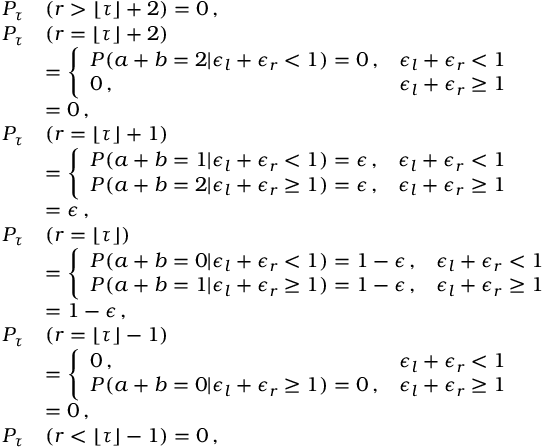Convert formula to latex. <formula><loc_0><loc_0><loc_500><loc_500>\begin{array} { r l } { P _ { \tau } } & { ( r > \lfloor \tau \rfloor + 2 ) = 0 \, , } \\ { P _ { \tau } } & { ( r = \lfloor \tau \rfloor + 2 ) } \\ & { = \left \{ \begin{array} { l l } { P ( a + b = 2 | \epsilon _ { l } + \epsilon _ { r } < 1 ) = 0 \, , } & { \epsilon _ { l } + \epsilon _ { r } < 1 } \\ { 0 \, , } & { \epsilon _ { l } + \epsilon _ { r } \geq 1 } \end{array} } \\ & { = 0 \, , } \\ { P _ { \tau } } & { ( r = \lfloor \tau \rfloor + 1 ) } \\ & { = \left \{ \begin{array} { l l } { P ( a + b = 1 | \epsilon _ { l } + \epsilon _ { r } < 1 ) = \epsilon \, , } & { \epsilon _ { l } + \epsilon _ { r } < 1 } \\ { P ( a + b = 2 | \epsilon _ { l } + \epsilon _ { r } \geq 1 ) = \epsilon \, , } & { \epsilon _ { l } + \epsilon _ { r } \geq 1 } \end{array} } \\ & { = \epsilon \, , } \\ { P _ { \tau } } & { ( r = \lfloor \tau \rfloor ) } \\ & { = \left \{ \begin{array} { l l } { P ( a + b = 0 | \epsilon _ { l } + \epsilon _ { r } < 1 ) = 1 - \epsilon \, , } & { \epsilon _ { l } + \epsilon _ { r } < 1 } \\ { P ( a + b = 1 | \epsilon _ { l } + \epsilon _ { r } \geq 1 ) = 1 - \epsilon \, , } & { \epsilon _ { l } + \epsilon _ { r } \geq 1 } \end{array} } \\ & { = 1 - \epsilon \, , } \\ { P _ { \tau } } & { ( r = \lfloor \tau \rfloor - 1 ) } \\ & { = \left \{ \begin{array} { l l } { 0 \, , } & { \epsilon _ { l } + \epsilon _ { r } < 1 } \\ { P ( a + b = 0 | \epsilon _ { l } + \epsilon _ { r } \geq 1 ) = 0 \, , } & { \epsilon _ { l } + \epsilon _ { r } \geq 1 } \end{array} } \\ & { = 0 \, , } \\ { P _ { \tau } } & { ( r < \lfloor \tau \rfloor - 1 ) = 0 \, , } \end{array}</formula> 